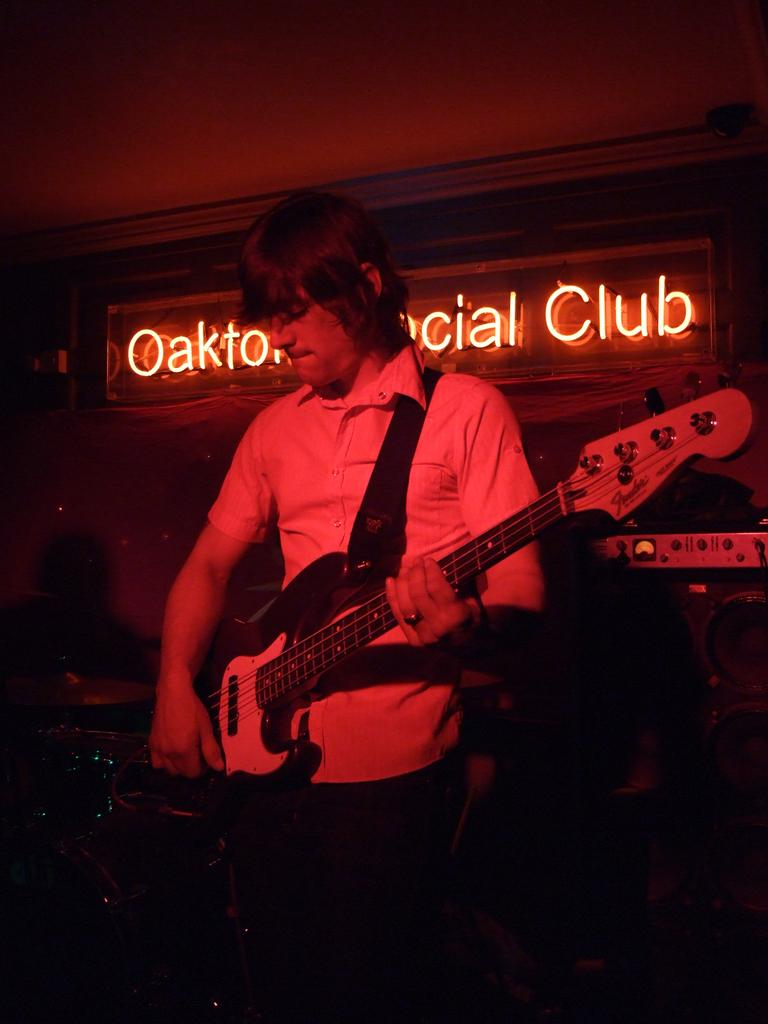What is the main subject of the image? The main subject of the image is a man. What is the man doing in the image? The man is playing a guitar in the image. What type of stone can be seen in the background of the image? There is no stone visible in the background of the image; it only features the man playing a guitar. 